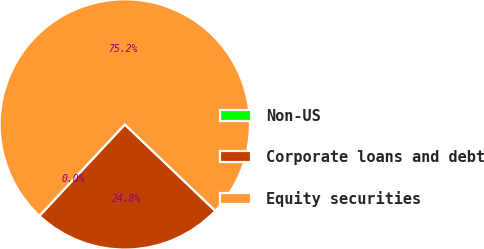Convert chart. <chart><loc_0><loc_0><loc_500><loc_500><pie_chart><fcel>Non-US<fcel>Corporate loans and debt<fcel>Equity securities<nl><fcel>0.03%<fcel>24.81%<fcel>75.16%<nl></chart> 